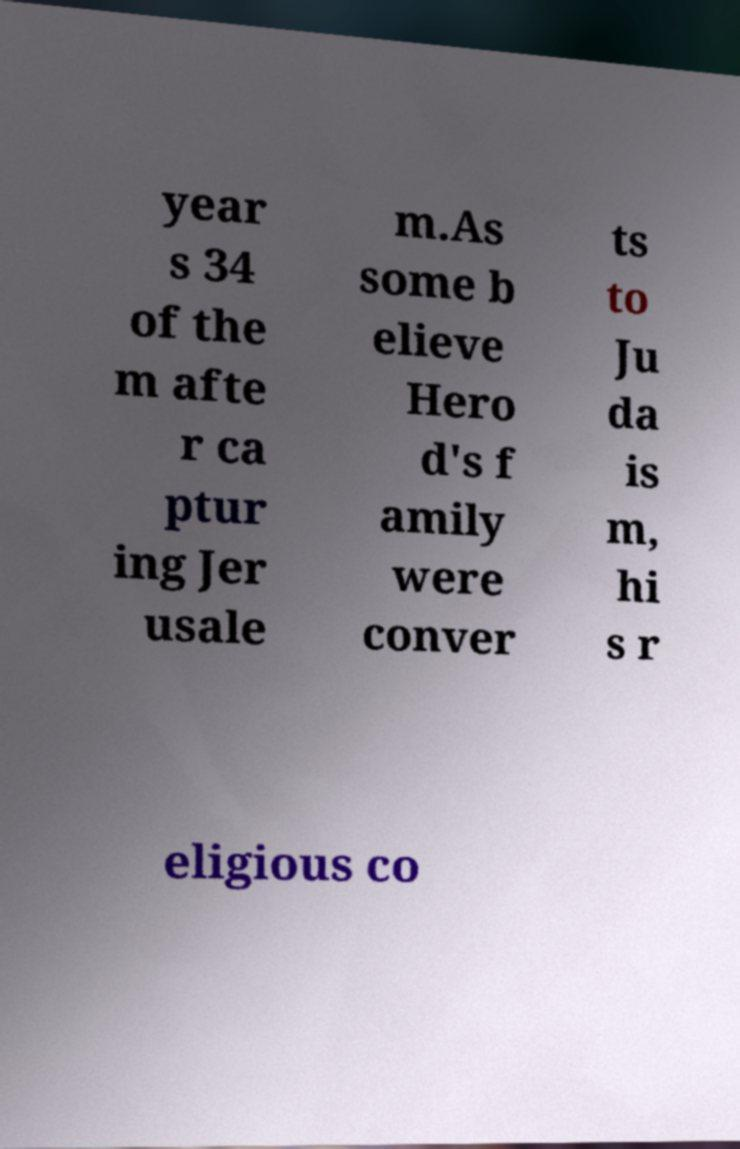Could you assist in decoding the text presented in this image and type it out clearly? year s 34 of the m afte r ca ptur ing Jer usale m.As some b elieve Hero d's f amily were conver ts to Ju da is m, hi s r eligious co 